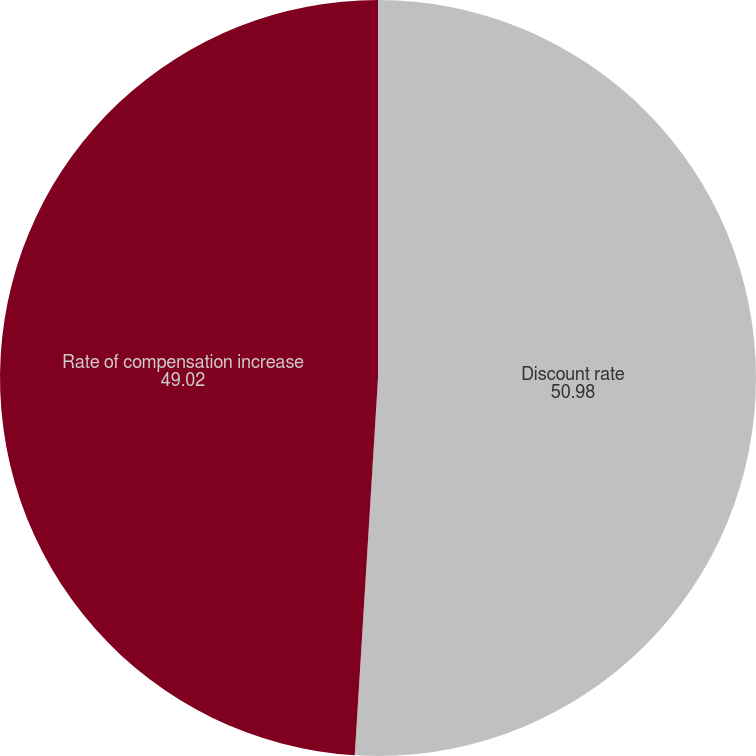Convert chart. <chart><loc_0><loc_0><loc_500><loc_500><pie_chart><fcel>Discount rate<fcel>Rate of compensation increase<nl><fcel>50.98%<fcel>49.02%<nl></chart> 